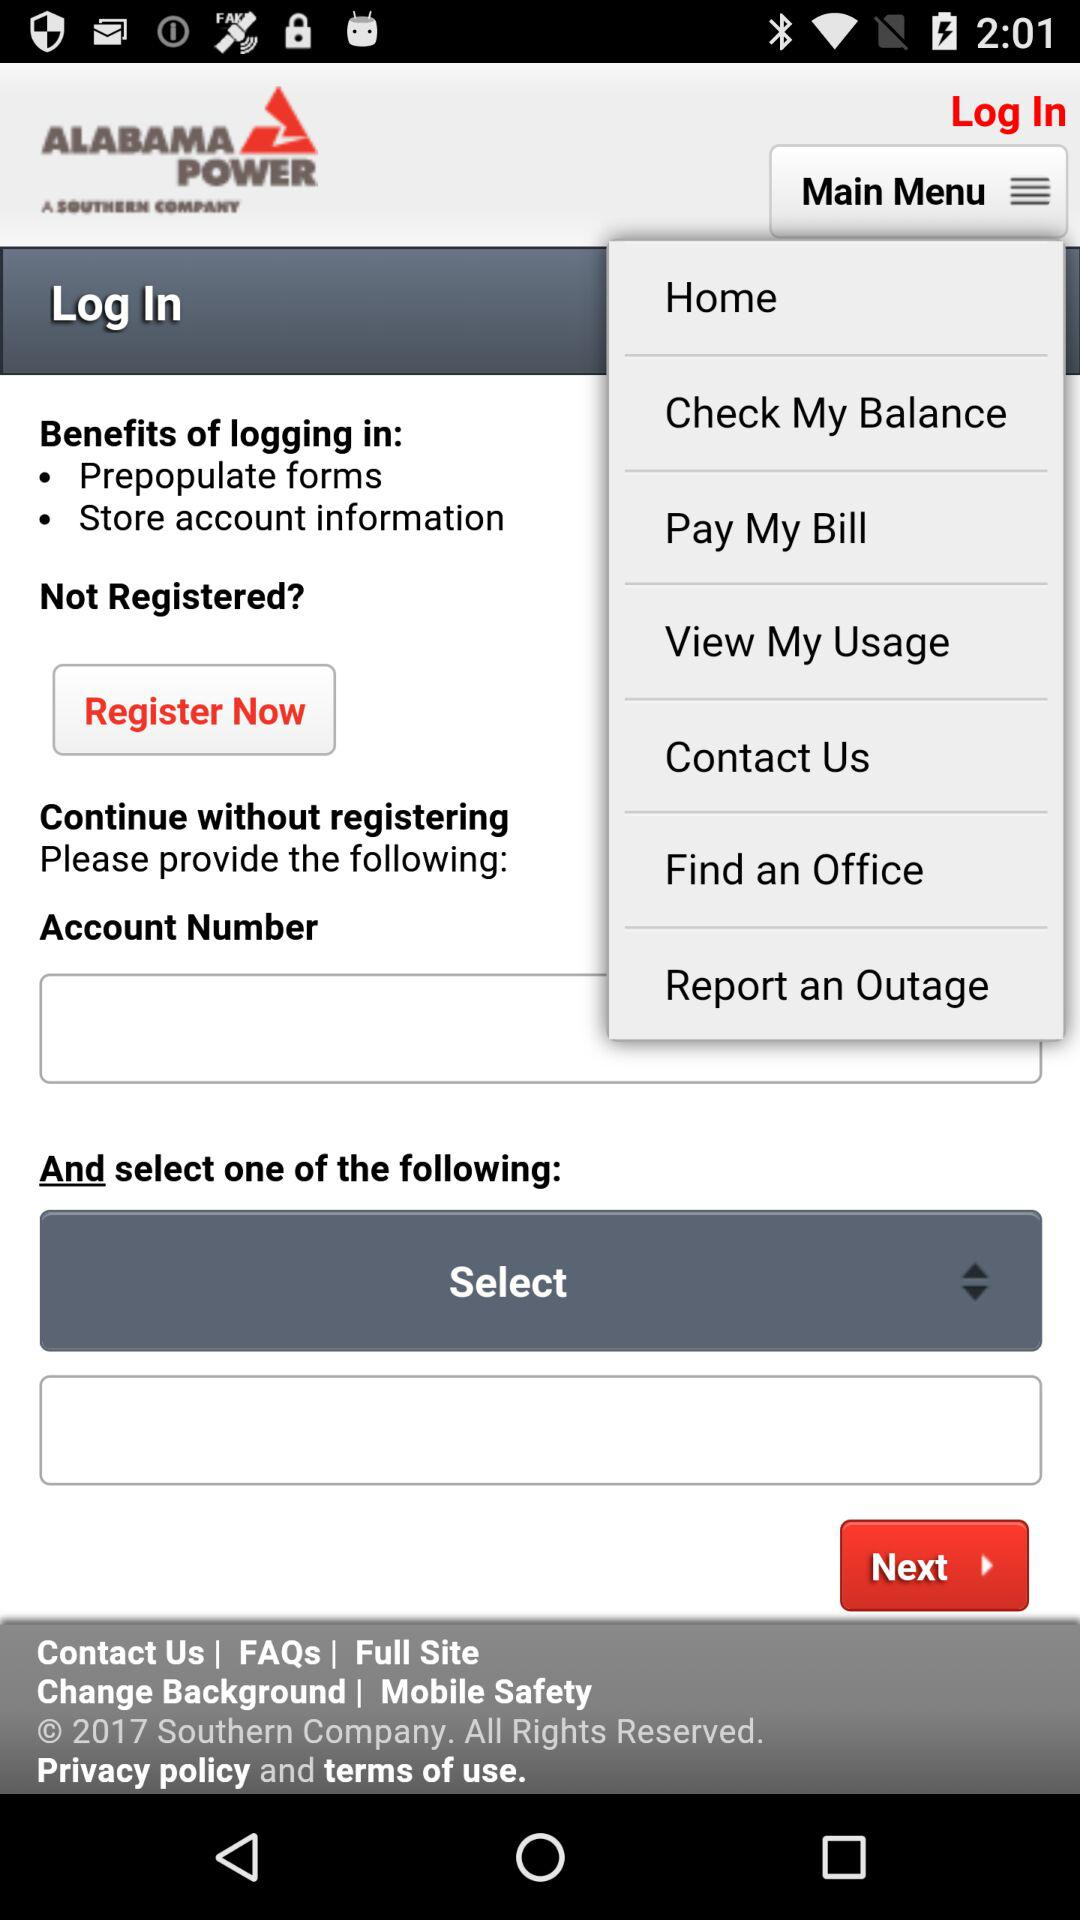How many text inputs are there that are not for account numbers?
Answer the question using a single word or phrase. 1 